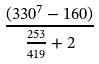Convert formula to latex. <formula><loc_0><loc_0><loc_500><loc_500>\frac { ( 3 3 0 ^ { 7 } - 1 6 0 ) } { \frac { 2 5 3 } { 4 1 9 } + 2 }</formula> 